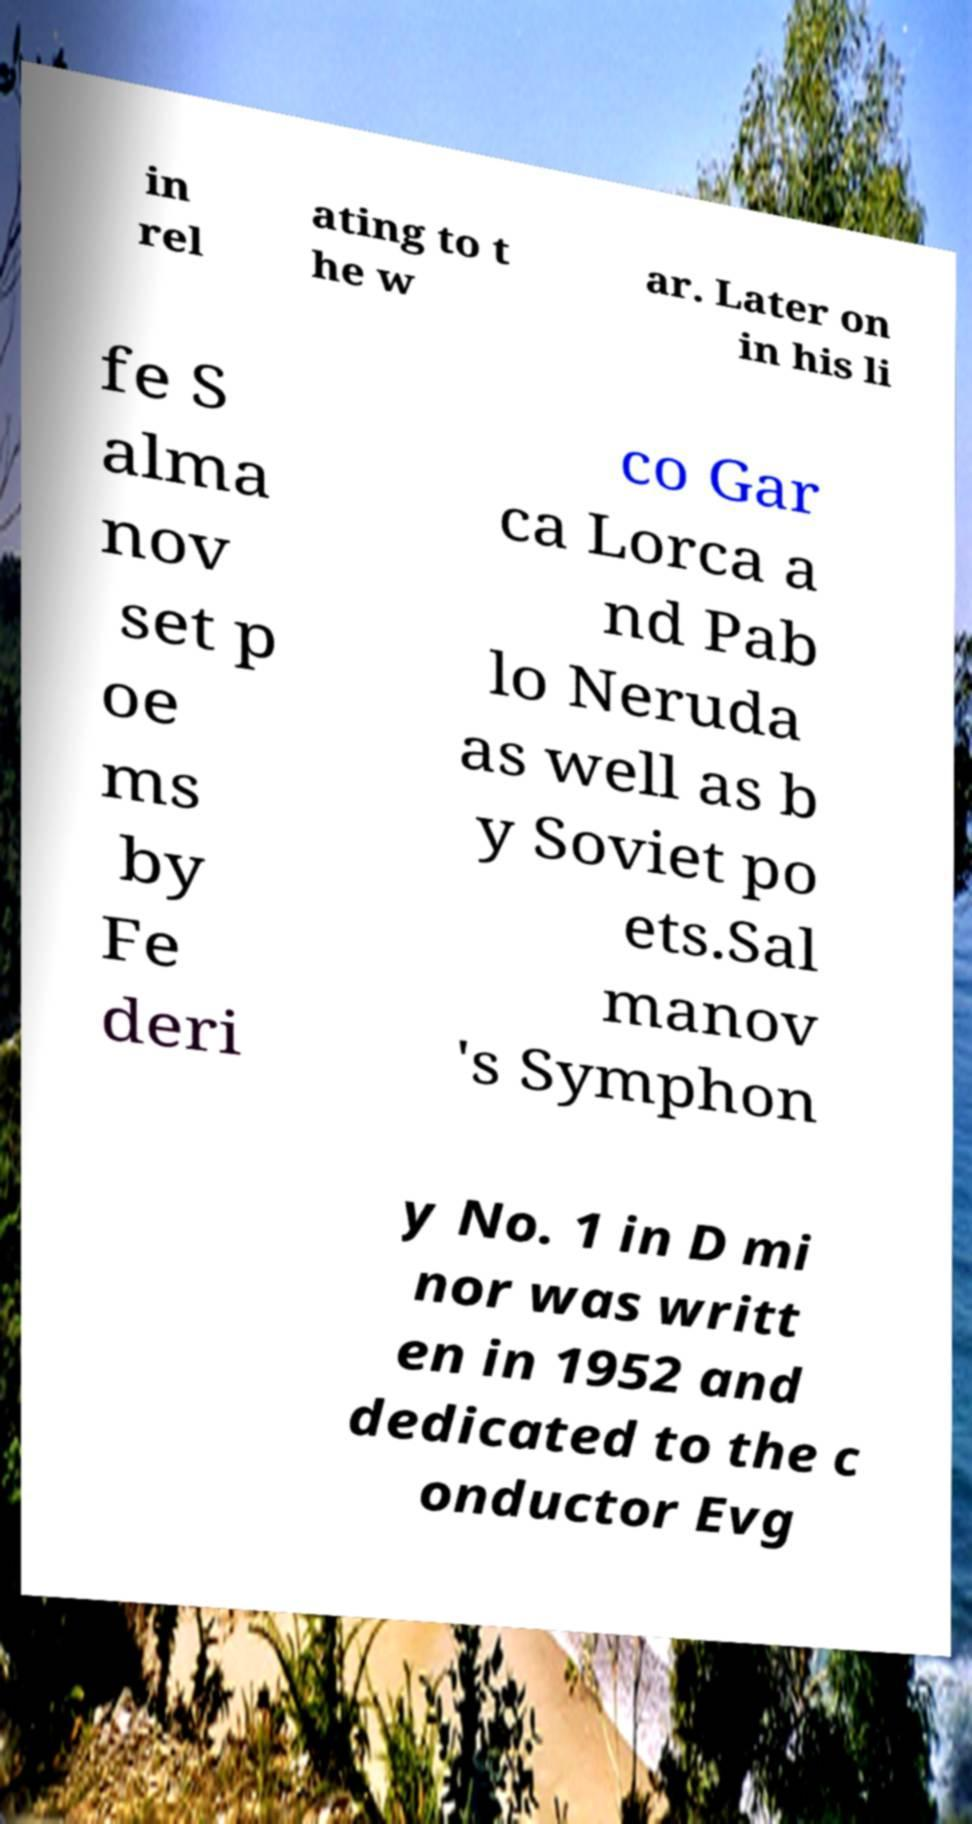Can you read and provide the text displayed in the image?This photo seems to have some interesting text. Can you extract and type it out for me? in rel ating to t he w ar. Later on in his li fe S alma nov set p oe ms by Fe deri co Gar ca Lorca a nd Pab lo Neruda as well as b y Soviet po ets.Sal manov 's Symphon y No. 1 in D mi nor was writt en in 1952 and dedicated to the c onductor Evg 